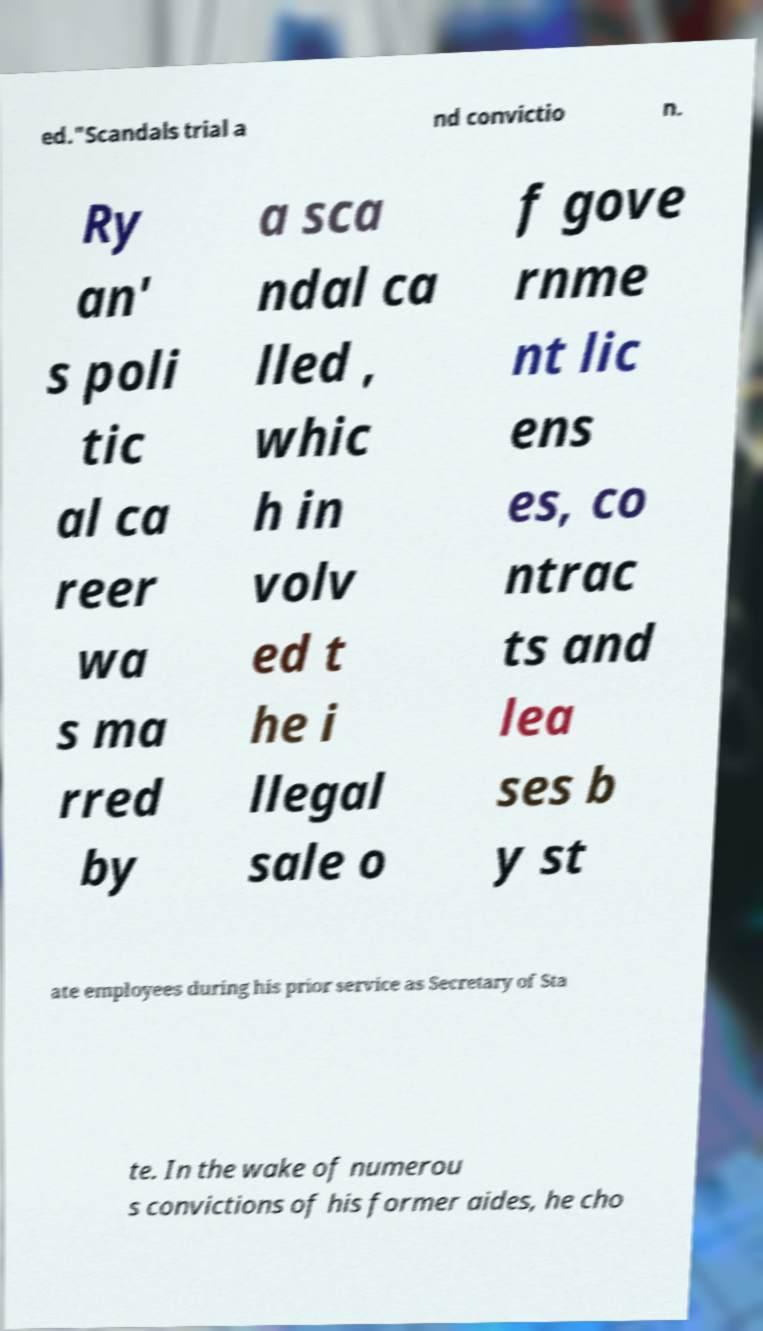Please read and relay the text visible in this image. What does it say? ed."Scandals trial a nd convictio n. Ry an' s poli tic al ca reer wa s ma rred by a sca ndal ca lled , whic h in volv ed t he i llegal sale o f gove rnme nt lic ens es, co ntrac ts and lea ses b y st ate employees during his prior service as Secretary of Sta te. In the wake of numerou s convictions of his former aides, he cho 